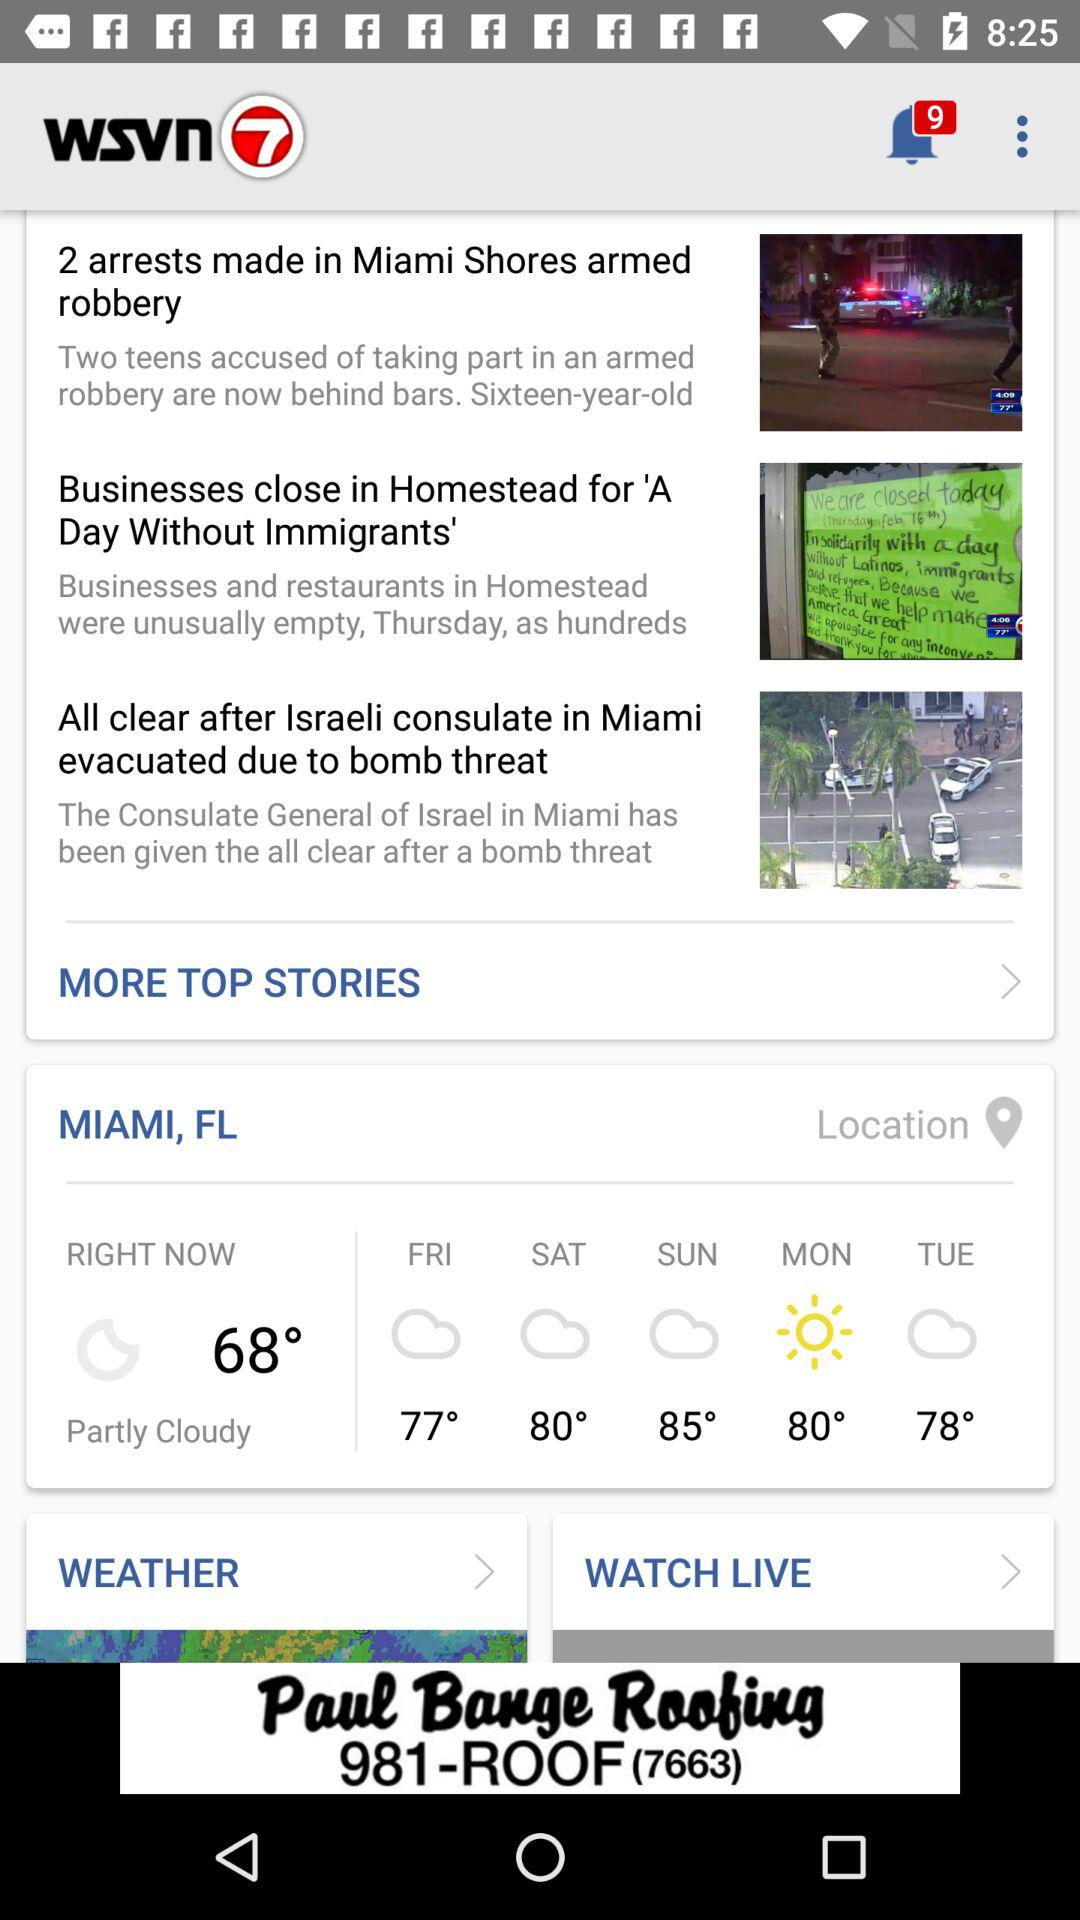How many more degrees is the high for Monday than the high for Friday?
Answer the question using a single word or phrase. 3 